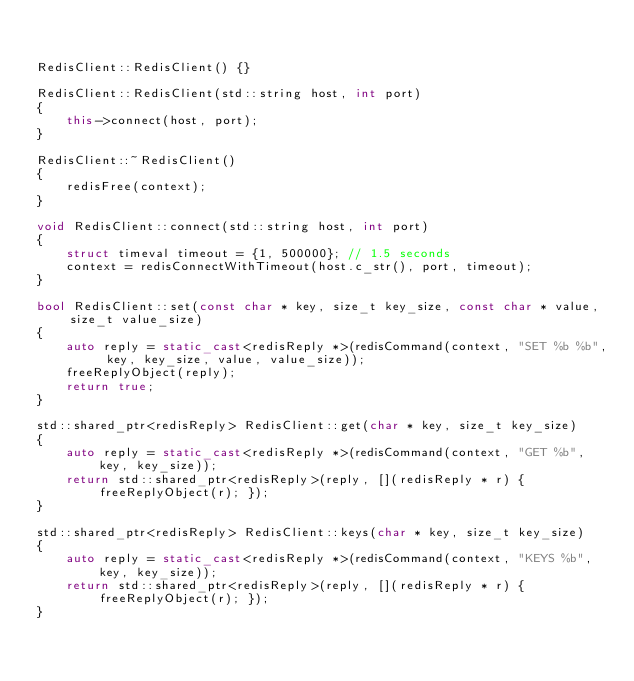Convert code to text. <code><loc_0><loc_0><loc_500><loc_500><_C++_>

RedisClient::RedisClient() {}

RedisClient::RedisClient(std::string host, int port)
{
    this->connect(host, port);
}

RedisClient::~RedisClient()
{
    redisFree(context);
}

void RedisClient::connect(std::string host, int port)
{
    struct timeval timeout = {1, 500000}; // 1.5 seconds
    context = redisConnectWithTimeout(host.c_str(), port, timeout);
}

bool RedisClient::set(const char * key, size_t key_size, const char * value, size_t value_size)
{
    auto reply = static_cast<redisReply *>(redisCommand(context, "SET %b %b", key, key_size, value, value_size));
    freeReplyObject(reply);
    return true;
}

std::shared_ptr<redisReply> RedisClient::get(char * key, size_t key_size)
{
    auto reply = static_cast<redisReply *>(redisCommand(context, "GET %b", key, key_size));
    return std::shared_ptr<redisReply>(reply, [](redisReply * r) { freeReplyObject(r); });
}

std::shared_ptr<redisReply> RedisClient::keys(char * key, size_t key_size)
{
    auto reply = static_cast<redisReply *>(redisCommand(context, "KEYS %b", key, key_size));
    return std::shared_ptr<redisReply>(reply, [](redisReply * r) { freeReplyObject(r); });
}
</code> 